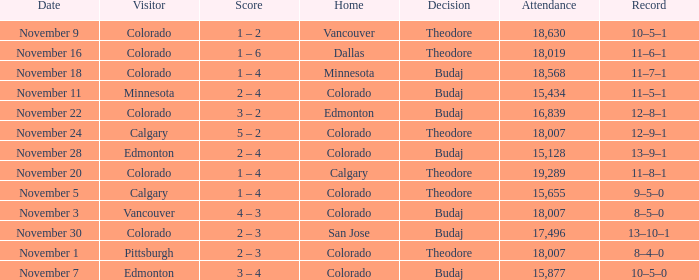Who was the Home Team while Calgary was visiting while having an Attendance above 15,655? Colorado. 